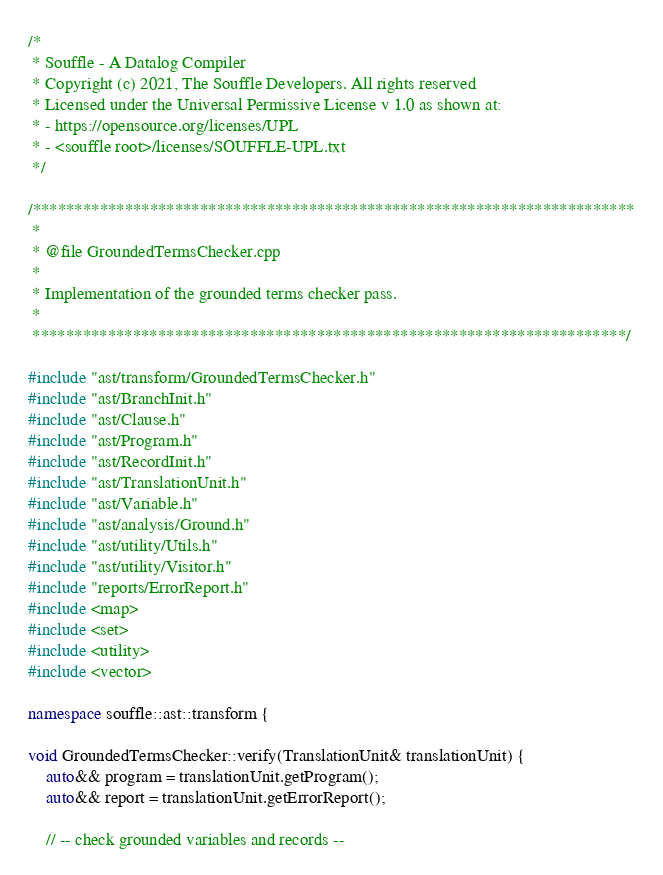Convert code to text. <code><loc_0><loc_0><loc_500><loc_500><_C++_>/*
 * Souffle - A Datalog Compiler
 * Copyright (c) 2021, The Souffle Developers. All rights reserved
 * Licensed under the Universal Permissive License v 1.0 as shown at:
 * - https://opensource.org/licenses/UPL
 * - <souffle root>/licenses/SOUFFLE-UPL.txt
 */

/************************************************************************
 *
 * @file GroundedTermsChecker.cpp
 *
 * Implementation of the grounded terms checker pass.
 *
 ***********************************************************************/

#include "ast/transform/GroundedTermsChecker.h"
#include "ast/BranchInit.h"
#include "ast/Clause.h"
#include "ast/Program.h"
#include "ast/RecordInit.h"
#include "ast/TranslationUnit.h"
#include "ast/Variable.h"
#include "ast/analysis/Ground.h"
#include "ast/utility/Utils.h"
#include "ast/utility/Visitor.h"
#include "reports/ErrorReport.h"
#include <map>
#include <set>
#include <utility>
#include <vector>

namespace souffle::ast::transform {

void GroundedTermsChecker::verify(TranslationUnit& translationUnit) {
    auto&& program = translationUnit.getProgram();
    auto&& report = translationUnit.getErrorReport();

    // -- check grounded variables and records --</code> 